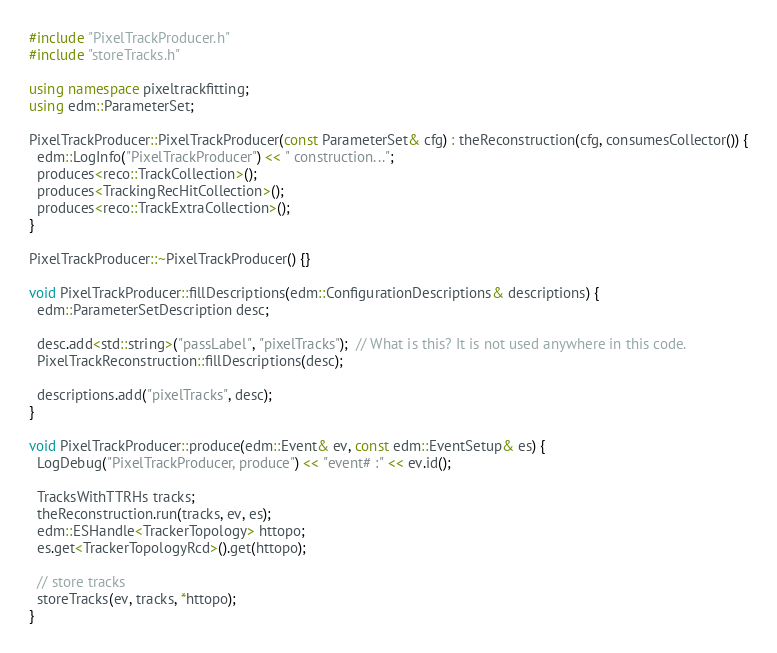<code> <loc_0><loc_0><loc_500><loc_500><_C++_>#include "PixelTrackProducer.h"
#include "storeTracks.h"

using namespace pixeltrackfitting;
using edm::ParameterSet;

PixelTrackProducer::PixelTrackProducer(const ParameterSet& cfg) : theReconstruction(cfg, consumesCollector()) {
  edm::LogInfo("PixelTrackProducer") << " construction...";
  produces<reco::TrackCollection>();
  produces<TrackingRecHitCollection>();
  produces<reco::TrackExtraCollection>();
}

PixelTrackProducer::~PixelTrackProducer() {}

void PixelTrackProducer::fillDescriptions(edm::ConfigurationDescriptions& descriptions) {
  edm::ParameterSetDescription desc;

  desc.add<std::string>("passLabel", "pixelTracks");  // What is this? It is not used anywhere in this code.
  PixelTrackReconstruction::fillDescriptions(desc);

  descriptions.add("pixelTracks", desc);
}

void PixelTrackProducer::produce(edm::Event& ev, const edm::EventSetup& es) {
  LogDebug("PixelTrackProducer, produce") << "event# :" << ev.id();

  TracksWithTTRHs tracks;
  theReconstruction.run(tracks, ev, es);
  edm::ESHandle<TrackerTopology> httopo;
  es.get<TrackerTopologyRcd>().get(httopo);

  // store tracks
  storeTracks(ev, tracks, *httopo);
}
</code> 